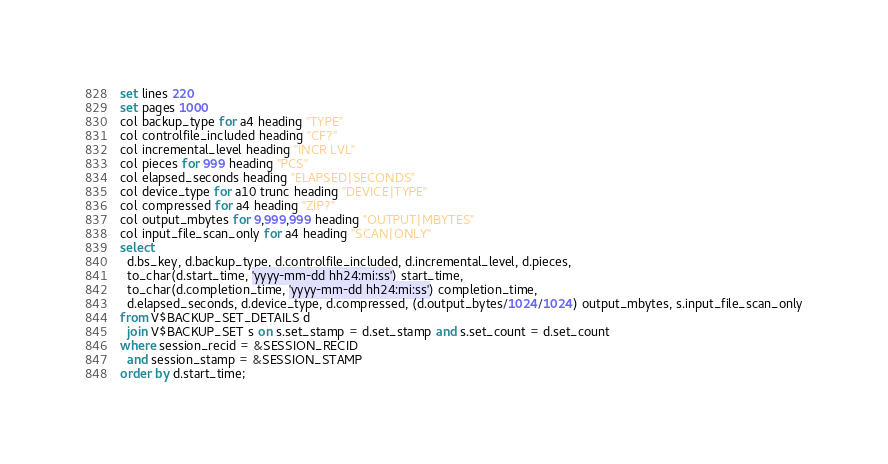<code> <loc_0><loc_0><loc_500><loc_500><_SQL_>set lines 220
set pages 1000
col backup_type for a4 heading "TYPE"
col controlfile_included heading "CF?"
col incremental_level heading "INCR LVL"
col pieces for 999 heading "PCS"
col elapsed_seconds heading "ELAPSED|SECONDS"
col device_type for a10 trunc heading "DEVICE|TYPE"
col compressed for a4 heading "ZIP?"
col output_mbytes for 9,999,999 heading "OUTPUT|MBYTES"
col input_file_scan_only for a4 heading "SCAN|ONLY"
select
  d.bs_key, d.backup_type, d.controlfile_included, d.incremental_level, d.pieces,
  to_char(d.start_time, 'yyyy-mm-dd hh24:mi:ss') start_time,
  to_char(d.completion_time, 'yyyy-mm-dd hh24:mi:ss') completion_time,
  d.elapsed_seconds, d.device_type, d.compressed, (d.output_bytes/1024/1024) output_mbytes, s.input_file_scan_only
from V$BACKUP_SET_DETAILS d
  join V$BACKUP_SET s on s.set_stamp = d.set_stamp and s.set_count = d.set_count
where session_recid = &SESSION_RECID
  and session_stamp = &SESSION_STAMP
order by d.start_time;</code> 